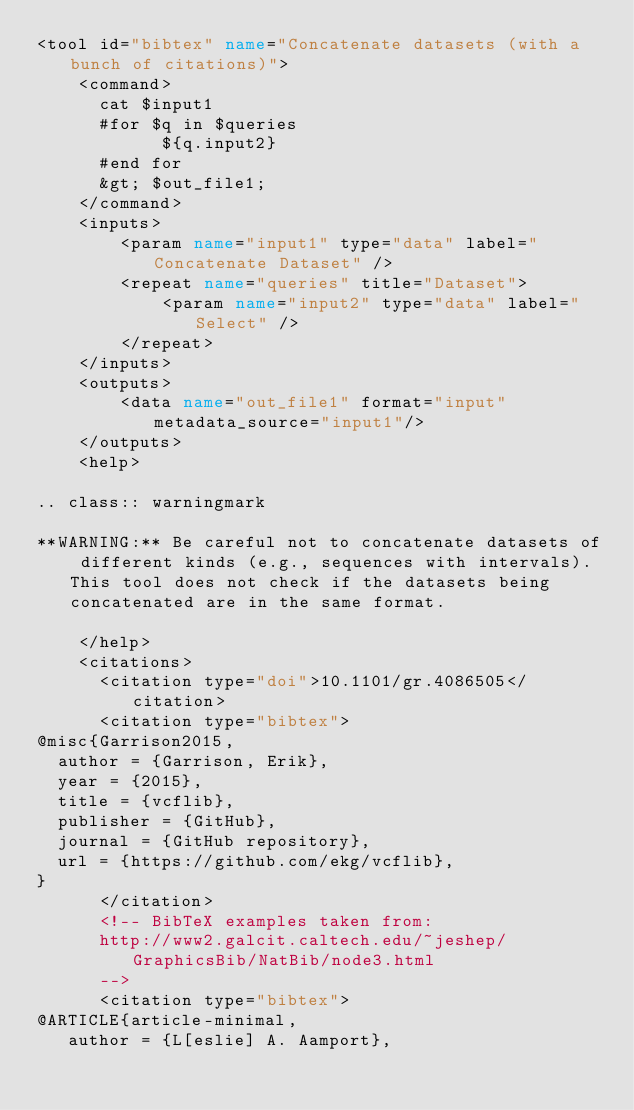<code> <loc_0><loc_0><loc_500><loc_500><_XML_><tool id="bibtex" name="Concatenate datasets (with a bunch of citations)">
    <command>
      cat $input1
      #for $q in $queries
            ${q.input2}
      #end for
      &gt; $out_file1;
    </command>
    <inputs>
        <param name="input1" type="data" label="Concatenate Dataset" />
        <repeat name="queries" title="Dataset">
            <param name="input2" type="data" label="Select" />
        </repeat>
    </inputs>
    <outputs>
        <data name="out_file1" format="input" metadata_source="input1"/>
    </outputs>
    <help>

.. class:: warningmark

**WARNING:** Be careful not to concatenate datasets of different kinds (e.g., sequences with intervals). This tool does not check if the datasets being concatenated are in the same format. 

    </help>
    <citations>
      <citation type="doi">10.1101/gr.4086505</citation>
      <citation type="bibtex">
@misc{Garrison2015,
  author = {Garrison, Erik},
  year = {2015},
  title = {vcflib},
  publisher = {GitHub},
  journal = {GitHub repository},
  url = {https://github.com/ekg/vcflib},
}
      </citation>
      <!-- BibTeX examples taken from:
      http://www2.galcit.caltech.edu/~jeshep/GraphicsBib/NatBib/node3.html
      -->
      <citation type="bibtex">
@ARTICLE{article-minimal,
   author = {L[eslie] A. Aamport},</code> 